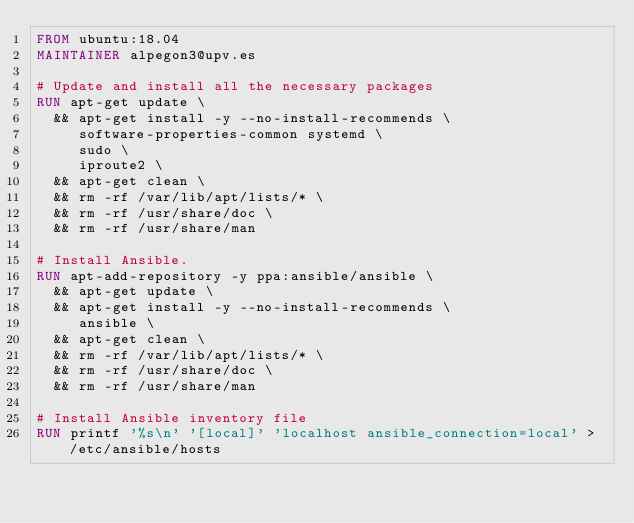<code> <loc_0><loc_0><loc_500><loc_500><_Dockerfile_>FROM ubuntu:18.04
MAINTAINER alpegon3@upv.es

# Update and install all the necessary packages
RUN apt-get update \
  && apt-get install -y --no-install-recommends \
     software-properties-common systemd \
     sudo \
     iproute2 \
  && apt-get clean \
  && rm -rf /var/lib/apt/lists/* \
  && rm -rf /usr/share/doc \
  && rm -rf /usr/share/man

# Install Ansible.
RUN apt-add-repository -y ppa:ansible/ansible \
  && apt-get update \
  && apt-get install -y --no-install-recommends \
     ansible \
  && apt-get clean \
  && rm -rf /var/lib/apt/lists/* \
  && rm -rf /usr/share/doc \
  && rm -rf /usr/share/man

# Install Ansible inventory file
RUN printf '%s\n' '[local]' 'localhost ansible_connection=local' > /etc/ansible/hosts
</code> 